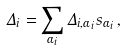<formula> <loc_0><loc_0><loc_500><loc_500>\Delta _ { i } = \sum _ { \alpha _ { i } } \Delta _ { i , \alpha _ { i } } s _ { \alpha _ { i } } \, ,</formula> 